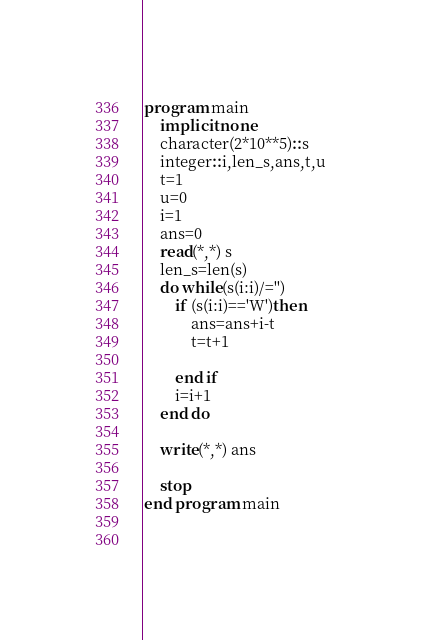<code> <loc_0><loc_0><loc_500><loc_500><_FORTRAN_>program main
	implicit none
    character(2*10**5)::s
    integer::i,len_s,ans,t,u
    t=1
    u=0
    i=1
    ans=0
    read(*,*) s
    len_s=len(s)
    do while(s(i:i)/='')
    	if (s(i:i)=='W')then
        	ans=ans+i-t
            t=t+1
            
        end if
        i=i+1
    end do
    
    write(*,*) ans
    
    stop
end program main
            
            </code> 